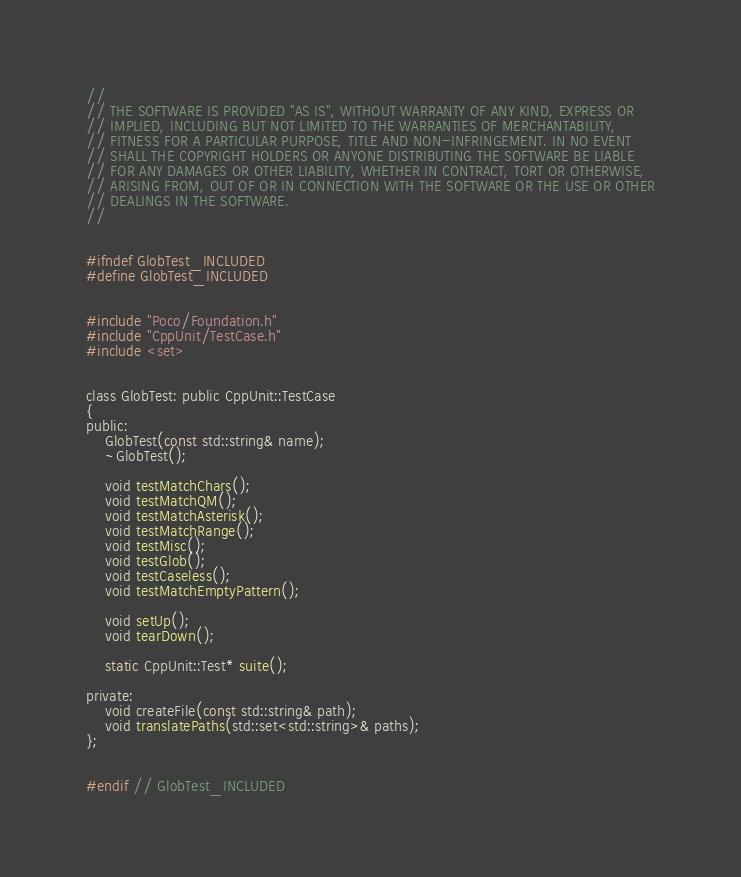<code> <loc_0><loc_0><loc_500><loc_500><_C_>// 
// THE SOFTWARE IS PROVIDED "AS IS", WITHOUT WARRANTY OF ANY KIND, EXPRESS OR
// IMPLIED, INCLUDING BUT NOT LIMITED TO THE WARRANTIES OF MERCHANTABILITY,
// FITNESS FOR A PARTICULAR PURPOSE, TITLE AND NON-INFRINGEMENT. IN NO EVENT
// SHALL THE COPYRIGHT HOLDERS OR ANYONE DISTRIBUTING THE SOFTWARE BE LIABLE
// FOR ANY DAMAGES OR OTHER LIABILITY, WHETHER IN CONTRACT, TORT OR OTHERWISE,
// ARISING FROM, OUT OF OR IN CONNECTION WITH THE SOFTWARE OR THE USE OR OTHER
// DEALINGS IN THE SOFTWARE.
//


#ifndef GlobTest_INCLUDED
#define GlobTest_INCLUDED


#include "Poco/Foundation.h"
#include "CppUnit/TestCase.h"
#include <set>


class GlobTest: public CppUnit::TestCase
{
public:
	GlobTest(const std::string& name);
	~GlobTest();

	void testMatchChars();
	void testMatchQM();
	void testMatchAsterisk();
	void testMatchRange();
	void testMisc();
	void testGlob();
	void testCaseless();
	void testMatchEmptyPattern();

	void setUp();
	void tearDown();

	static CppUnit::Test* suite();

private:
	void createFile(const std::string& path);
	void translatePaths(std::set<std::string>& paths);
};


#endif // GlobTest_INCLUDED
</code> 